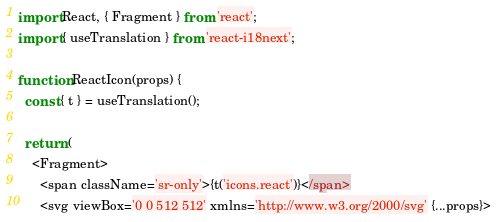<code> <loc_0><loc_0><loc_500><loc_500><_JavaScript_>import React, { Fragment } from 'react';
import { useTranslation } from 'react-i18next';

function ReactIcon(props) {
  const { t } = useTranslation();

  return (
    <Fragment>
      <span className='sr-only'>{t('icons.react')}</span>
      <svg viewBox='0 0 512 512' xmlns='http://www.w3.org/2000/svg' {...props}></code> 